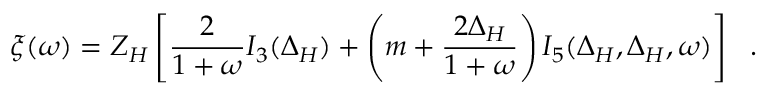Convert formula to latex. <formula><loc_0><loc_0><loc_500><loc_500>\xi ( \omega ) = Z _ { H } \left [ \frac { 2 } { 1 + \omega } I _ { 3 } ( \Delta _ { H } ) + \left ( m + \frac { 2 \Delta _ { H } } { 1 + \omega } \right ) I _ { 5 } ( \Delta _ { H } , \Delta _ { H } , \omega ) \right ] .</formula> 